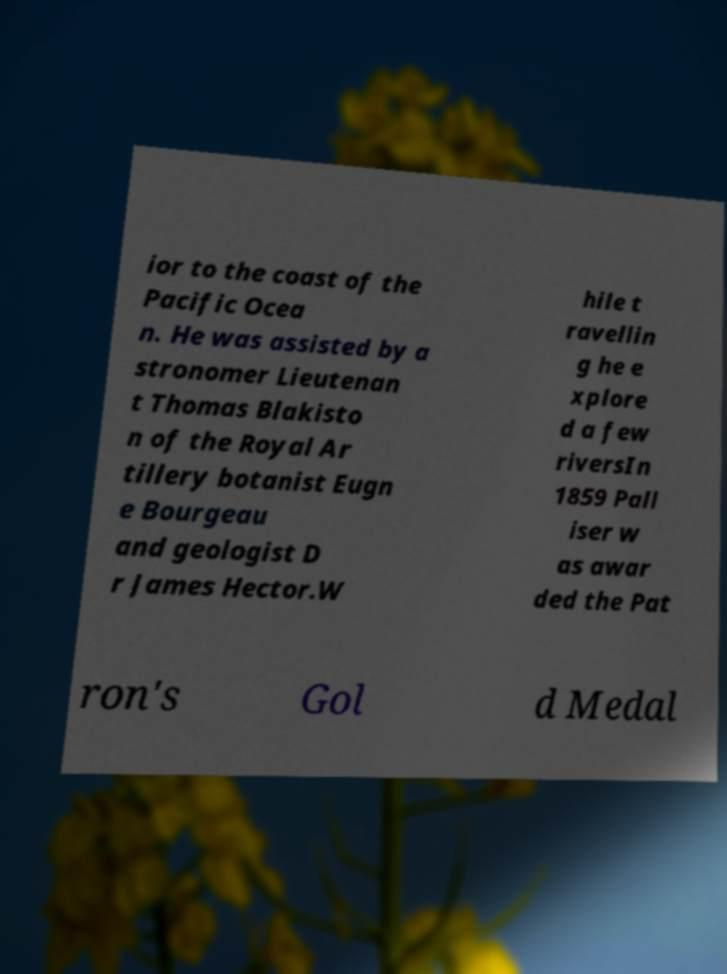There's text embedded in this image that I need extracted. Can you transcribe it verbatim? ior to the coast of the Pacific Ocea n. He was assisted by a stronomer Lieutenan t Thomas Blakisto n of the Royal Ar tillery botanist Eugn e Bourgeau and geologist D r James Hector.W hile t ravellin g he e xplore d a few riversIn 1859 Pall iser w as awar ded the Pat ron's Gol d Medal 